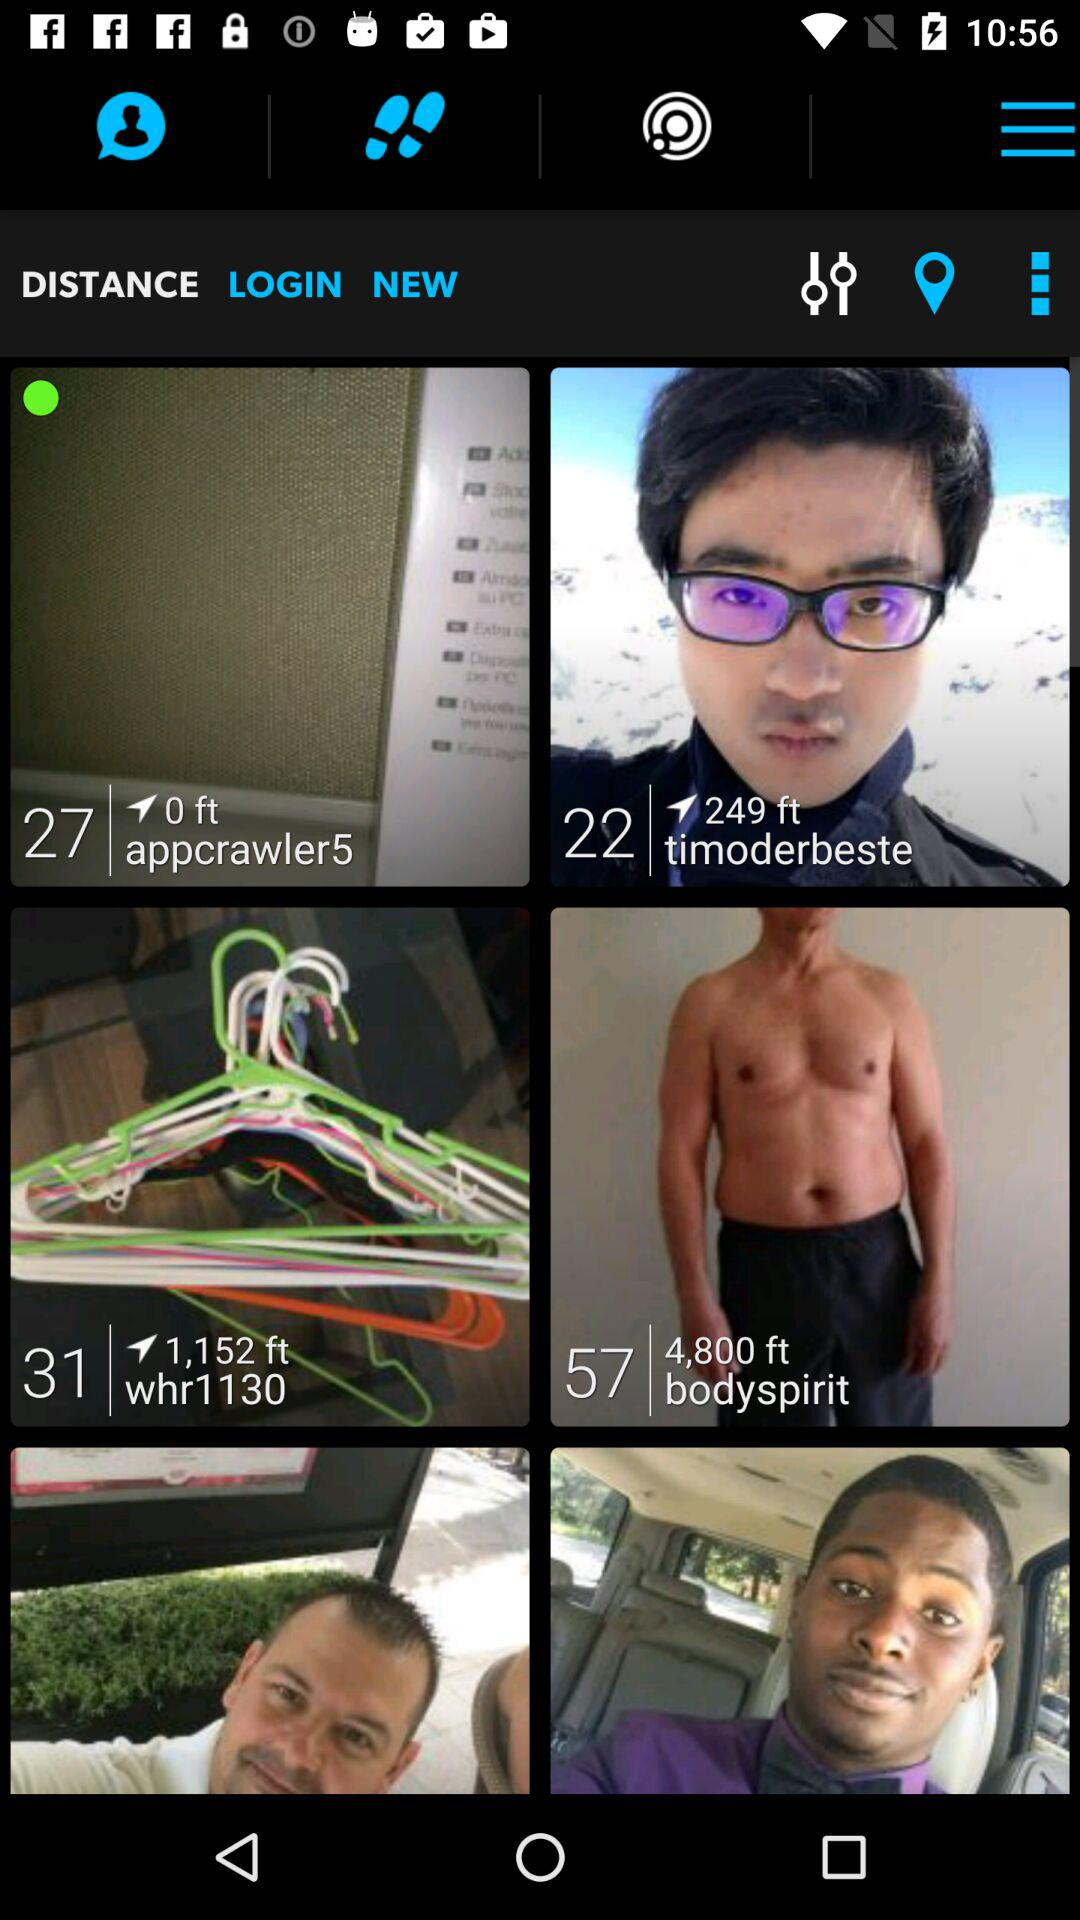What is the username of the person who is at the height of 4,800 ft? The username is "bodyspirit". 